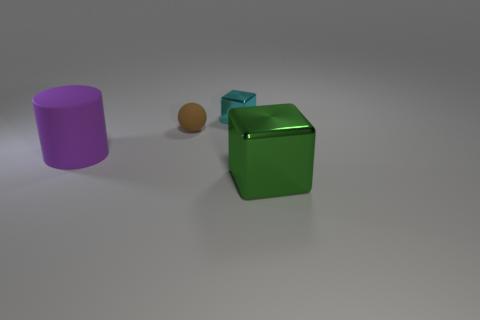Add 3 large green cubes. How many objects exist? 7 Subtract all spheres. How many objects are left? 3 Subtract all large cyan metallic cubes. Subtract all large purple cylinders. How many objects are left? 3 Add 4 brown spheres. How many brown spheres are left? 5 Add 2 tiny shiny cubes. How many tiny shiny cubes exist? 3 Subtract 0 yellow cylinders. How many objects are left? 4 